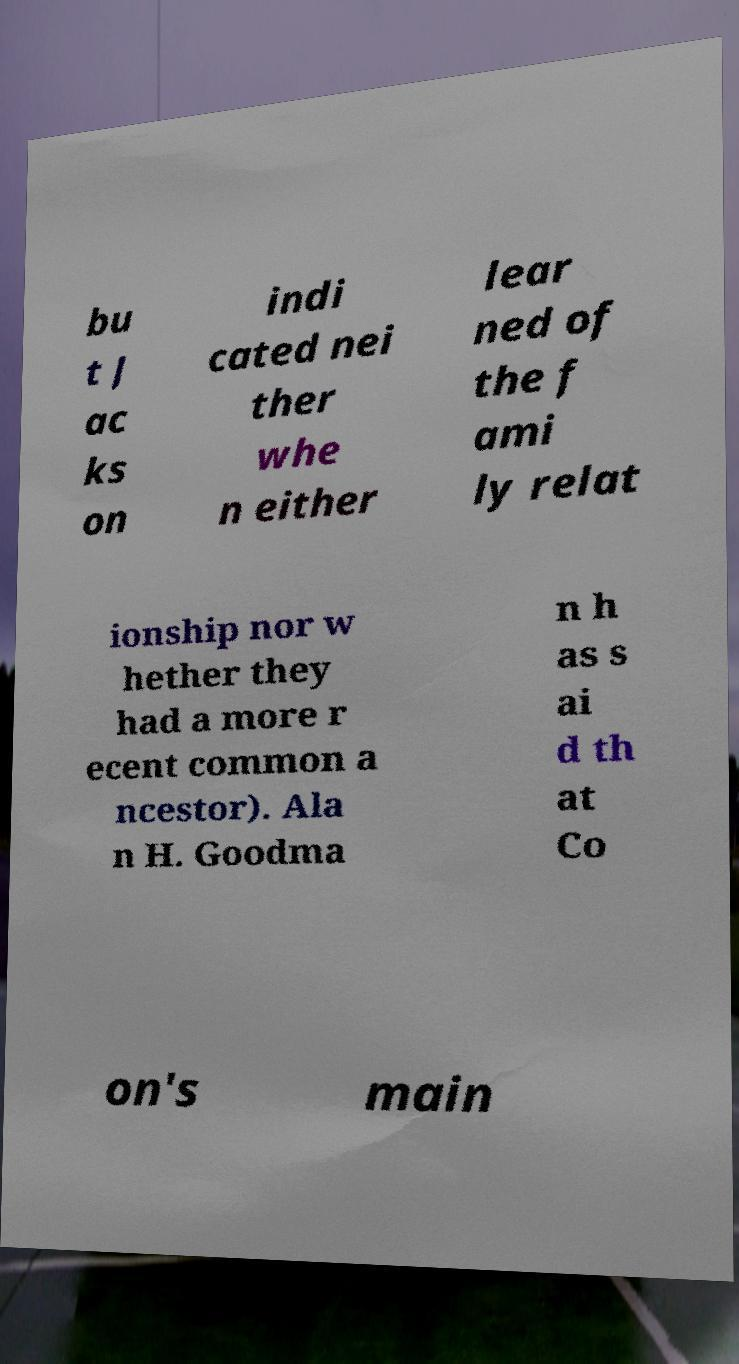Please identify and transcribe the text found in this image. bu t J ac ks on indi cated nei ther whe n either lear ned of the f ami ly relat ionship nor w hether they had a more r ecent common a ncestor). Ala n H. Goodma n h as s ai d th at Co on's main 